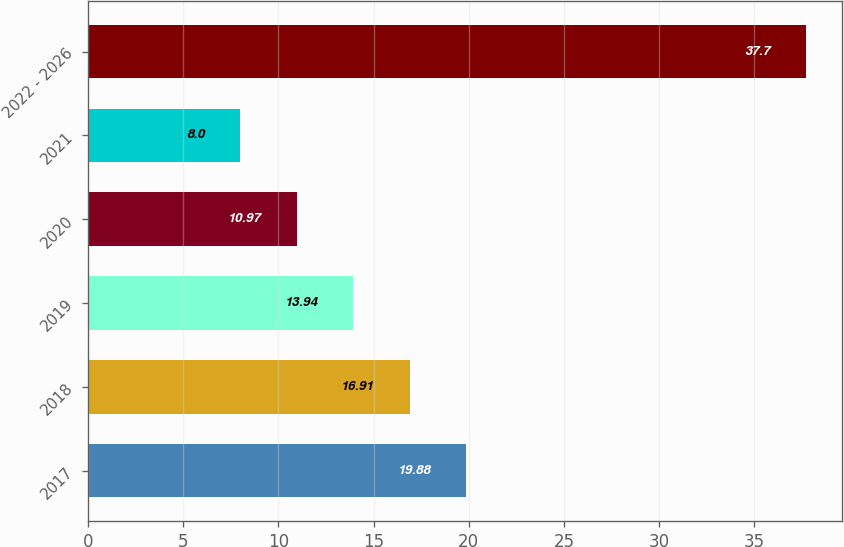<chart> <loc_0><loc_0><loc_500><loc_500><bar_chart><fcel>2017<fcel>2018<fcel>2019<fcel>2020<fcel>2021<fcel>2022 - 2026<nl><fcel>19.88<fcel>16.91<fcel>13.94<fcel>10.97<fcel>8<fcel>37.7<nl></chart> 